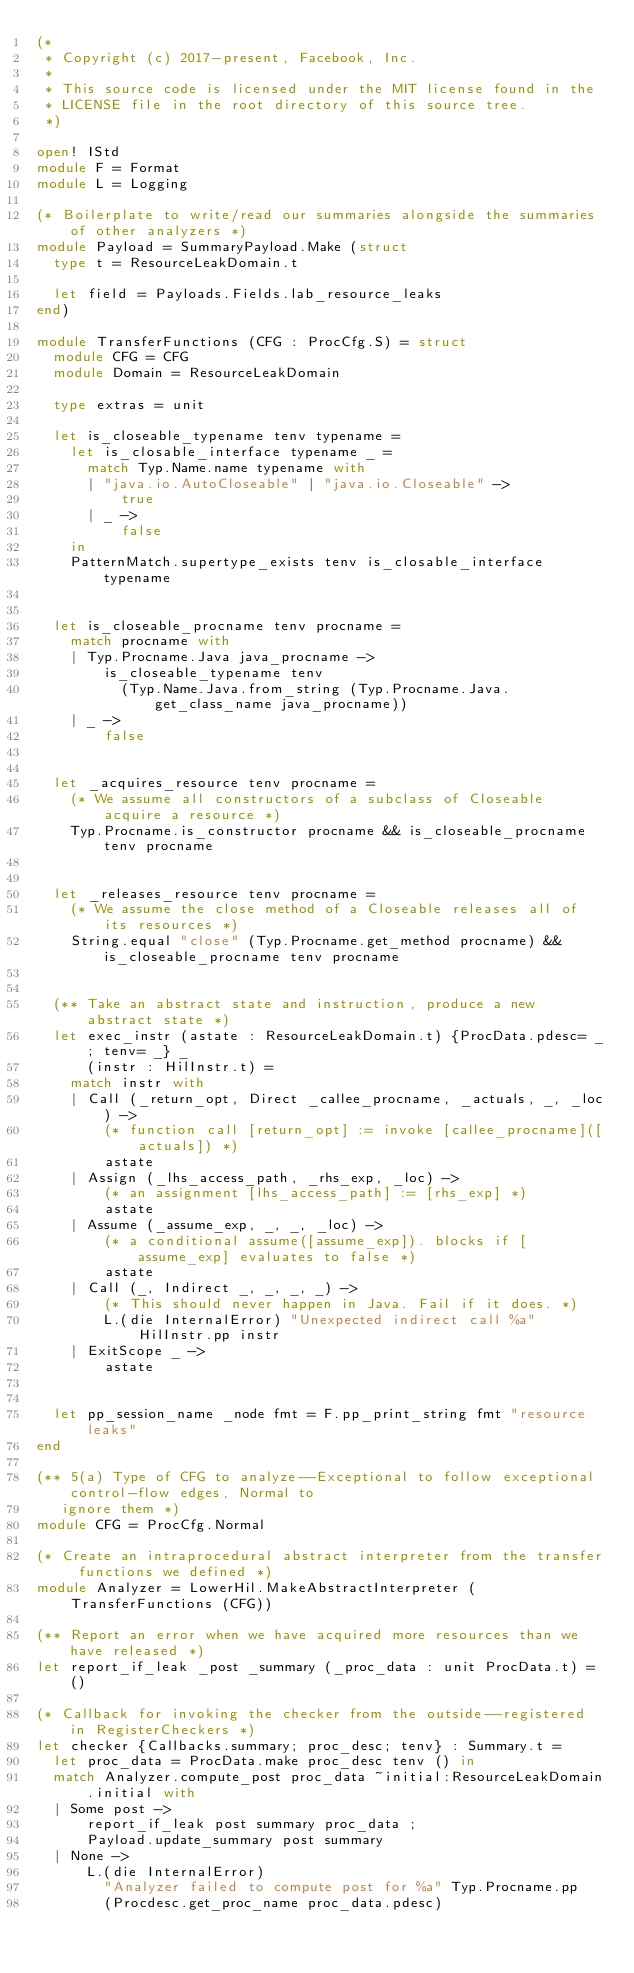Convert code to text. <code><loc_0><loc_0><loc_500><loc_500><_OCaml_>(*
 * Copyright (c) 2017-present, Facebook, Inc.
 *
 * This source code is licensed under the MIT license found in the
 * LICENSE file in the root directory of this source tree.
 *)

open! IStd
module F = Format
module L = Logging

(* Boilerplate to write/read our summaries alongside the summaries of other analyzers *)
module Payload = SummaryPayload.Make (struct
  type t = ResourceLeakDomain.t

  let field = Payloads.Fields.lab_resource_leaks
end)

module TransferFunctions (CFG : ProcCfg.S) = struct
  module CFG = CFG
  module Domain = ResourceLeakDomain

  type extras = unit

  let is_closeable_typename tenv typename =
    let is_closable_interface typename _ =
      match Typ.Name.name typename with
      | "java.io.AutoCloseable" | "java.io.Closeable" ->
          true
      | _ ->
          false
    in
    PatternMatch.supertype_exists tenv is_closable_interface typename


  let is_closeable_procname tenv procname =
    match procname with
    | Typ.Procname.Java java_procname ->
        is_closeable_typename tenv
          (Typ.Name.Java.from_string (Typ.Procname.Java.get_class_name java_procname))
    | _ ->
        false


  let _acquires_resource tenv procname =
    (* We assume all constructors of a subclass of Closeable acquire a resource *)
    Typ.Procname.is_constructor procname && is_closeable_procname tenv procname


  let _releases_resource tenv procname =
    (* We assume the close method of a Closeable releases all of its resources *)
    String.equal "close" (Typ.Procname.get_method procname) && is_closeable_procname tenv procname


  (** Take an abstract state and instruction, produce a new abstract state *)
  let exec_instr (astate : ResourceLeakDomain.t) {ProcData.pdesc= _; tenv= _} _
      (instr : HilInstr.t) =
    match instr with
    | Call (_return_opt, Direct _callee_procname, _actuals, _, _loc) ->
        (* function call [return_opt] := invoke [callee_procname]([actuals]) *)
        astate
    | Assign (_lhs_access_path, _rhs_exp, _loc) ->
        (* an assignment [lhs_access_path] := [rhs_exp] *)
        astate
    | Assume (_assume_exp, _, _, _loc) ->
        (* a conditional assume([assume_exp]). blocks if [assume_exp] evaluates to false *)
        astate
    | Call (_, Indirect _, _, _, _) ->
        (* This should never happen in Java. Fail if it does. *)
        L.(die InternalError) "Unexpected indirect call %a" HilInstr.pp instr
    | ExitScope _ ->
        astate


  let pp_session_name _node fmt = F.pp_print_string fmt "resource leaks"
end

(** 5(a) Type of CFG to analyze--Exceptional to follow exceptional control-flow edges, Normal to
   ignore them *)
module CFG = ProcCfg.Normal

(* Create an intraprocedural abstract interpreter from the transfer functions we defined *)
module Analyzer = LowerHil.MakeAbstractInterpreter (TransferFunctions (CFG))

(** Report an error when we have acquired more resources than we have released *)
let report_if_leak _post _summary (_proc_data : unit ProcData.t) = ()

(* Callback for invoking the checker from the outside--registered in RegisterCheckers *)
let checker {Callbacks.summary; proc_desc; tenv} : Summary.t =
  let proc_data = ProcData.make proc_desc tenv () in
  match Analyzer.compute_post proc_data ~initial:ResourceLeakDomain.initial with
  | Some post ->
      report_if_leak post summary proc_data ;
      Payload.update_summary post summary
  | None ->
      L.(die InternalError)
        "Analyzer failed to compute post for %a" Typ.Procname.pp
        (Procdesc.get_proc_name proc_data.pdesc)
</code> 